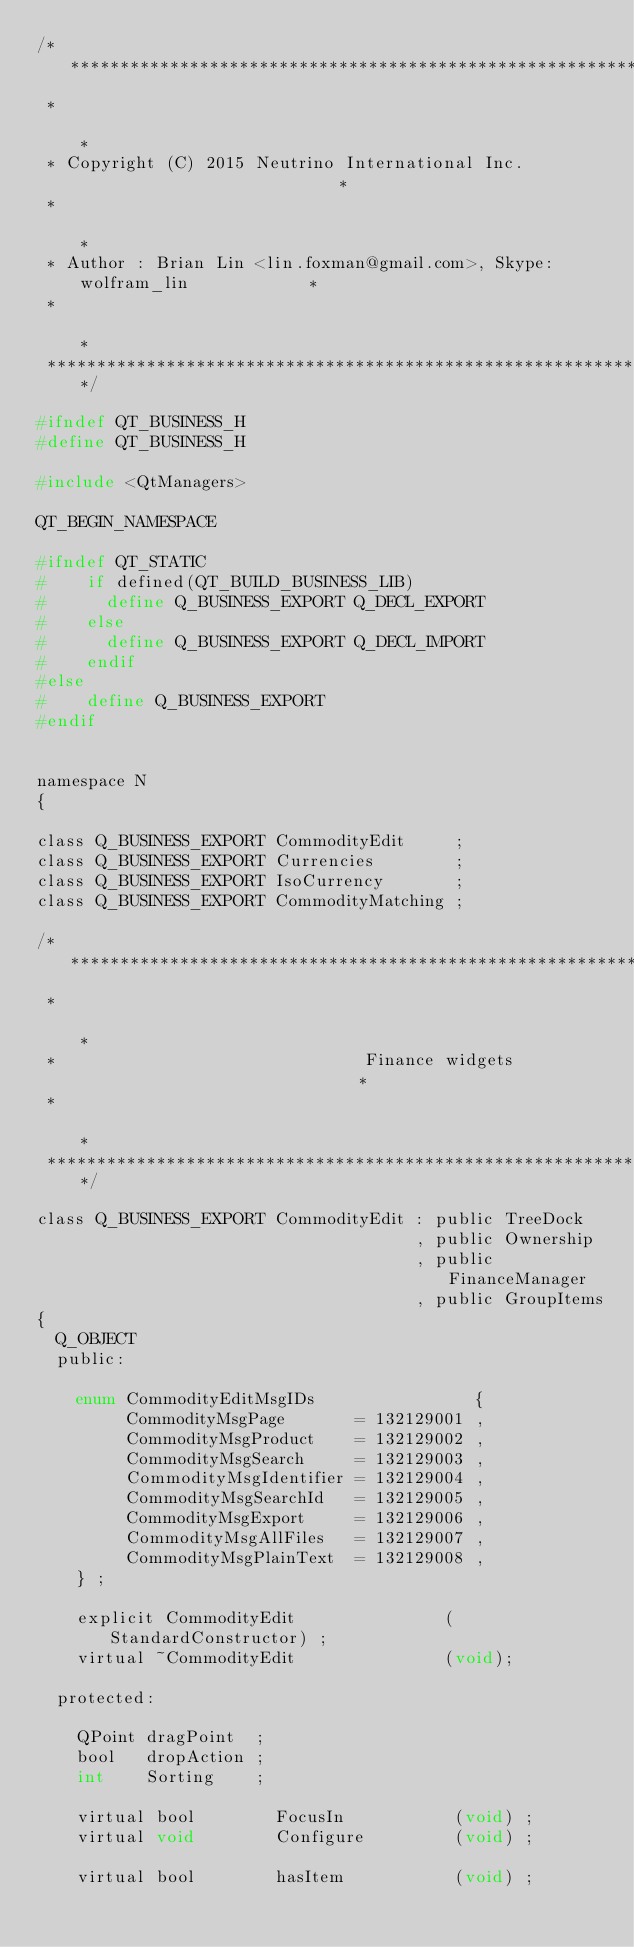<code> <loc_0><loc_0><loc_500><loc_500><_C_>/****************************************************************************
 *                                                                          *
 * Copyright (C) 2015 Neutrino International Inc.                           *
 *                                                                          *
 * Author : Brian Lin <lin.foxman@gmail.com>, Skype: wolfram_lin            *
 *                                                                          *
 ****************************************************************************/

#ifndef QT_BUSINESS_H
#define QT_BUSINESS_H

#include <QtManagers>

QT_BEGIN_NAMESPACE

#ifndef QT_STATIC
#    if defined(QT_BUILD_BUSINESS_LIB)
#      define Q_BUSINESS_EXPORT Q_DECL_EXPORT
#    else
#      define Q_BUSINESS_EXPORT Q_DECL_IMPORT
#    endif
#else
#    define Q_BUSINESS_EXPORT
#endif


namespace N
{

class Q_BUSINESS_EXPORT CommodityEdit     ;
class Q_BUSINESS_EXPORT Currencies        ;
class Q_BUSINESS_EXPORT IsoCurrency       ;
class Q_BUSINESS_EXPORT CommodityMatching ;

/*****************************************************************************
 *                                                                           *
 *                               Finance widgets                             *
 *                                                                           *
 *****************************************************************************/

class Q_BUSINESS_EXPORT CommodityEdit : public TreeDock
                                      , public Ownership
                                      , public FinanceManager
                                      , public GroupItems
{
  Q_OBJECT
  public:

    enum CommodityEditMsgIDs                {
         CommodityMsgPage       = 132129001 ,
         CommodityMsgProduct    = 132129002 ,
         CommodityMsgSearch     = 132129003 ,
         CommodityMsgIdentifier = 132129004 ,
         CommodityMsgSearchId   = 132129005 ,
         CommodityMsgExport     = 132129006 ,
         CommodityMsgAllFiles   = 132129007 ,
         CommodityMsgPlainText  = 132129008 ,
    } ;

    explicit CommodityEdit               (StandardConstructor) ;
    virtual ~CommodityEdit               (void);

  protected:

    QPoint dragPoint  ;
    bool   dropAction ;
    int    Sorting    ;

    virtual bool        FocusIn           (void) ;
    virtual void        Configure         (void) ;

    virtual bool        hasItem           (void) ;</code> 